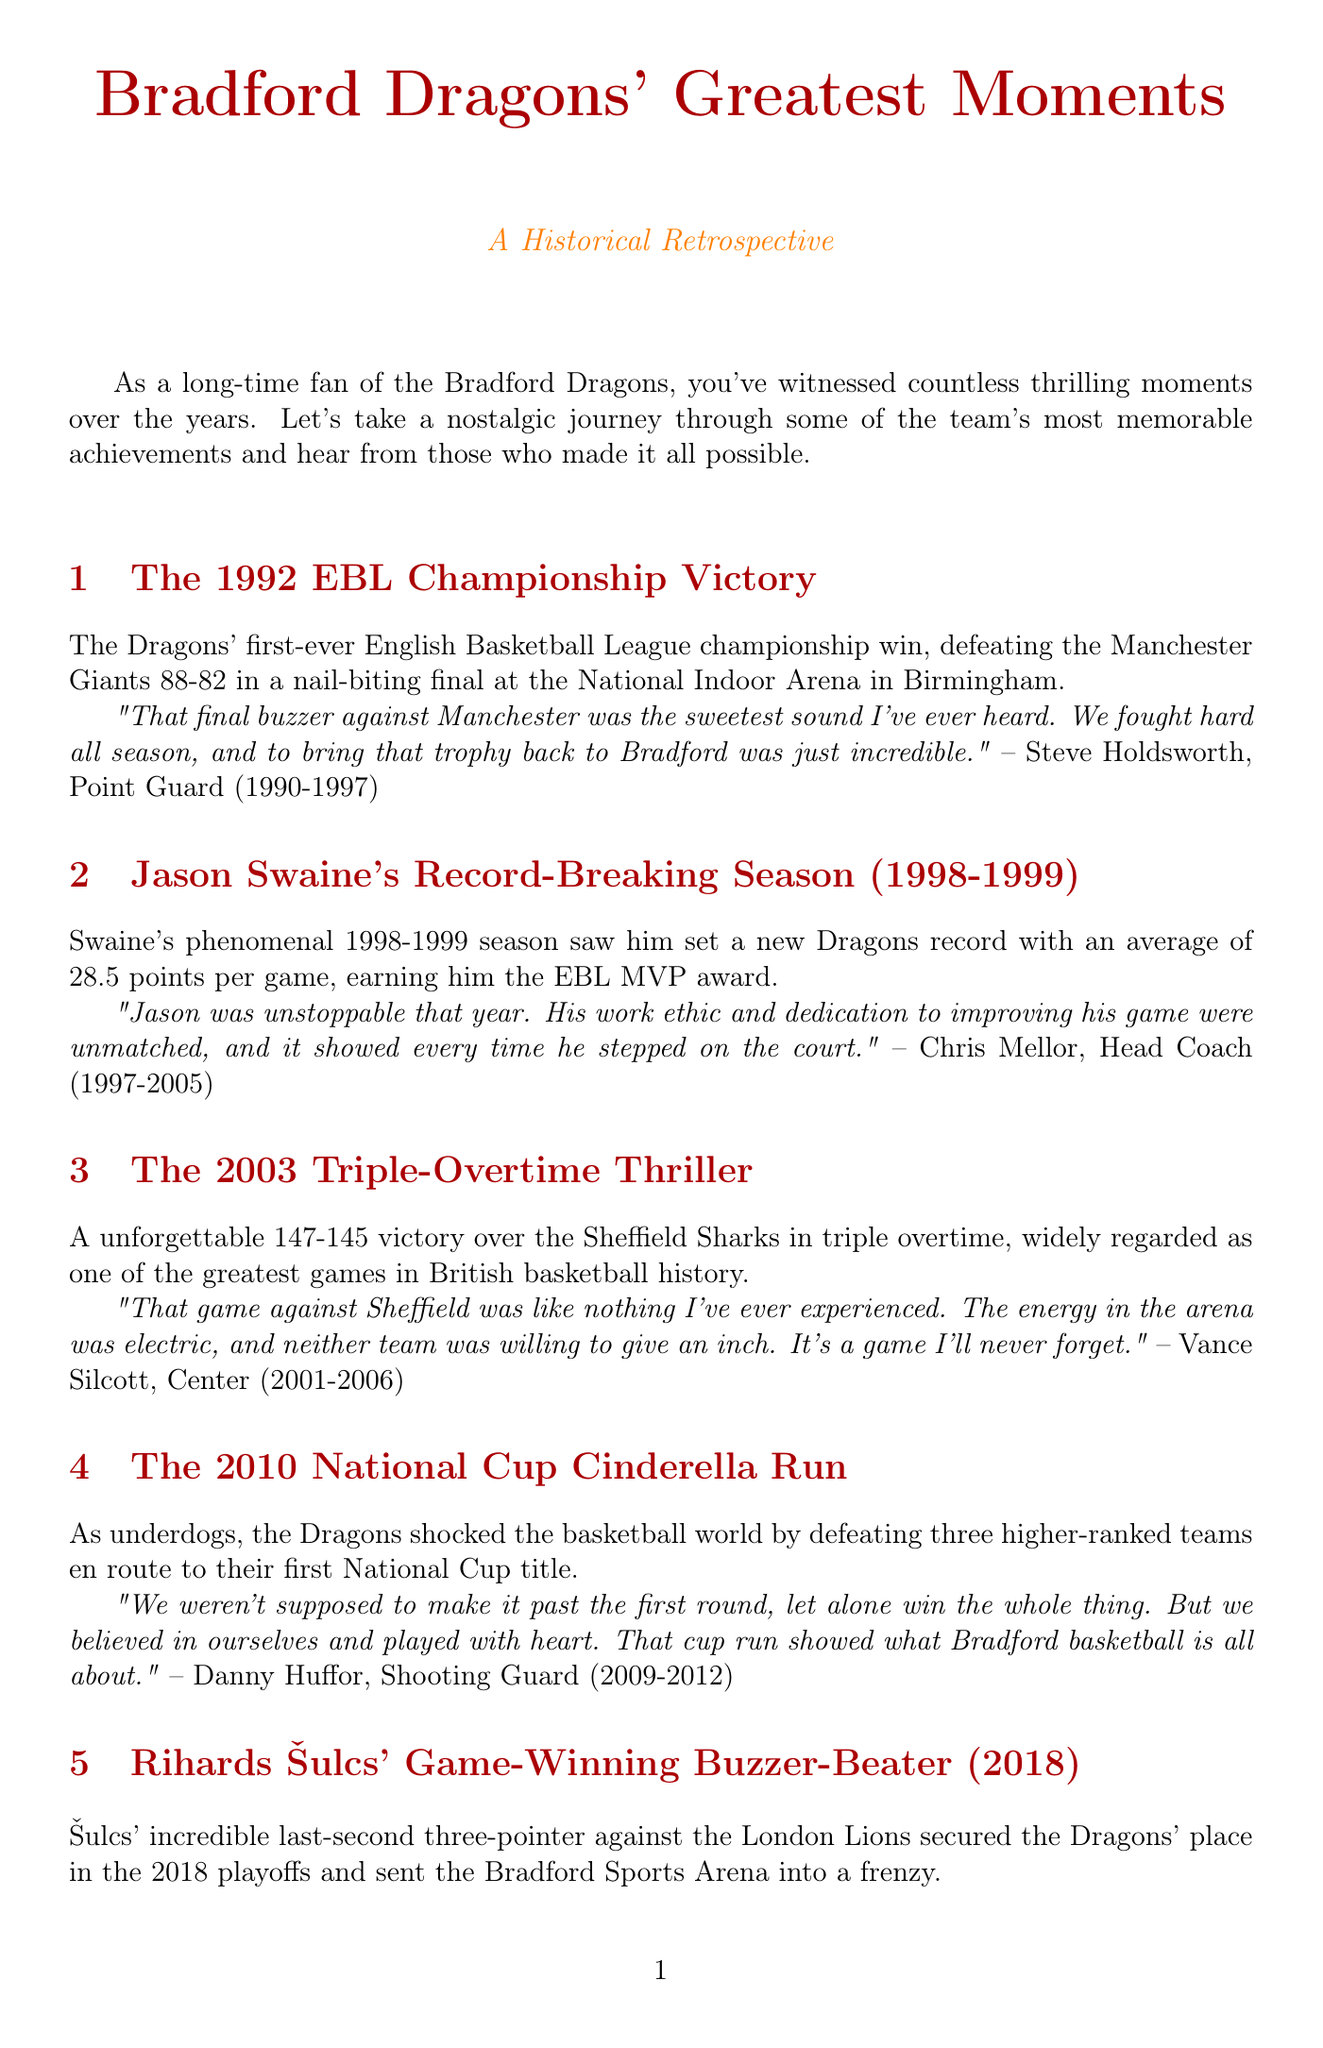What year did the Dragons win their first EBL Championship? The document states that the Dragons won their first EBL Championship in 1992.
Answer: 1992 Who was the head coach during Jason Swaine's record-breaking season? The document mentions Chris Mellor as the head coach during the 1998-1999 season when Swaine set his record.
Answer: Chris Mellor What was Jason Swaine's average points per game in the 1998-1999 season? The document specifies that Swaine had an average of 28.5 points per game during that season.
Answer: 28.5 How many overtimes were played in the 2003 game against the Sheffield Sharks? The document notes that the game went into triple overtime.
Answer: Triple What was the final score of the unforgettable game against Sheffield in 2003? According to the document, the final score was 147-145 in favor of the Dragons.
Answer: 147-145 Who made the game-winning buzzer-beater in 2018? The document indicates that Rihards Šulcs made the last-second three-pointer.
Answer: Rihards Šulcs What major achievement did the Dragons complete in 2010? The document describes the Dragons' Cinderella run, resulting in their first National Cup title.
Answer: First National Cup title How many higher-ranked teams did the Dragons defeat in the 2010 National Cup? The document states that they defeated three higher-ranked teams on their way to the title.
Answer: Three What was the quote from Danny Huffor regarding the 2010 cup run? The document contains a direct quote from Danny Huffor about self-belief and playing with heart during the cup run.
Answer: "But we believed in ourselves and played with heart." 